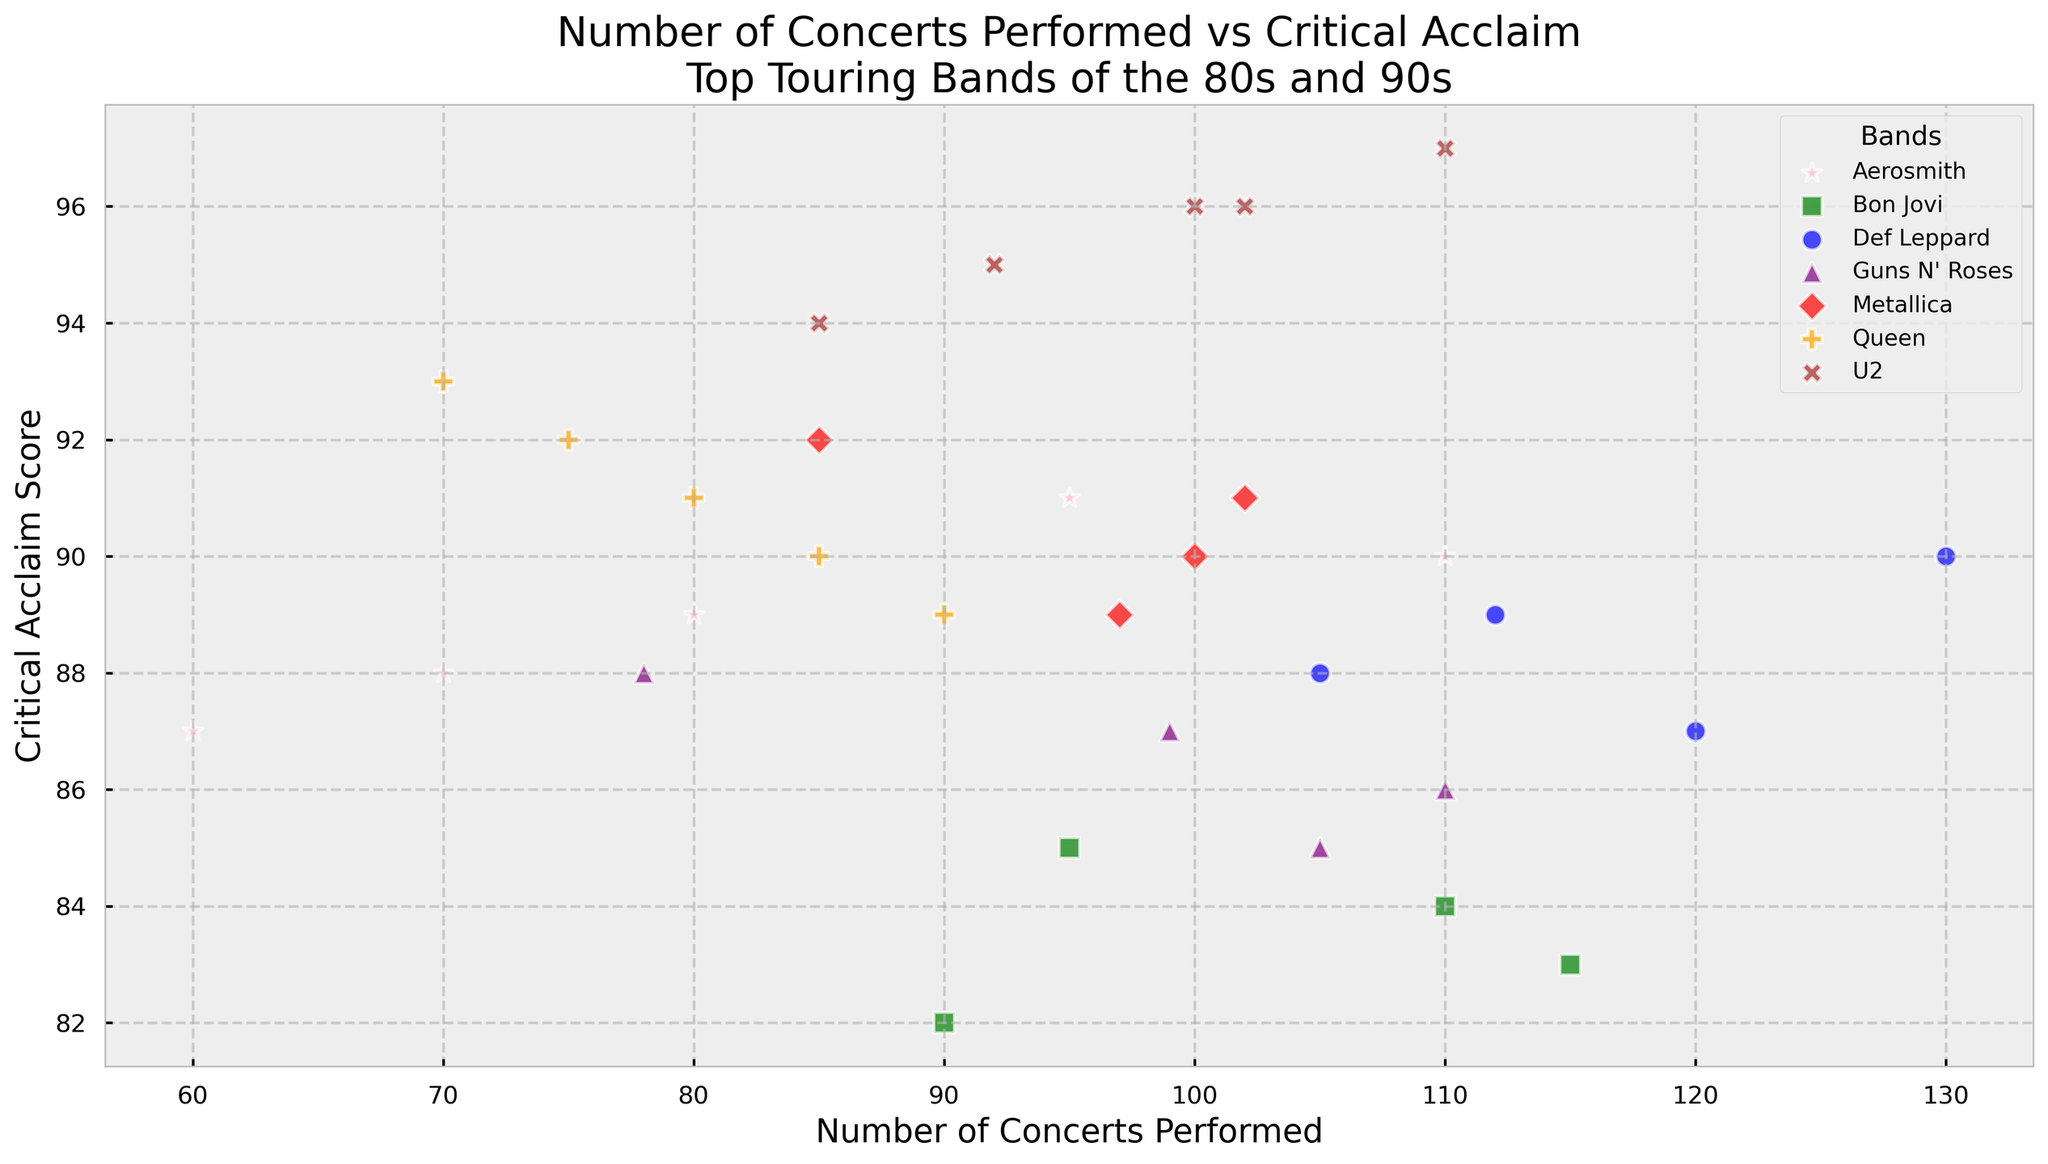What is the average critical acclaim score for concerts performed by U2? To find the average critical acclaim score for U2, identify the data points for U2, sum their critical acclaim scores, and divide by the number of data points. The scores are 94, 95, 96, 97, 96. Sum is 478. There are 5 data points, so the average is 478 / 5.
Answer: 95.6 Which band performed the most concerts in a single year, and what is the critical acclaim score for that year? To determine which band performed the most concerts, look for the highest value on the x-axis and identify the band. The band with the most concerts is Def Leppard with 130 concerts in 1987, and the score is 90.
Answer: Def Leppard, 90 Between Metallica and Guns N' Roses, which band had a year with the highest critical acclaim score, and what was the score? Compare the maximum y-axis values for Metallica and Guns N' Roses. Metallica's highest score is 92 in 1986. Guns N' Roses' highest score is 88 in 1987. Therefore, Metallica has the higher score with 92.
Answer: Metallica, 92 Did Def Leppard ever achieve a critical acclaim score greater than or equal to 90? If yes, in which years? To check, look at the critical acclaim scores for Def Leppard above or equal to 90. Def Leppard achieved a score of 90 in 1987.
Answer: Yes, 1987 What is the combined number of concerts performed by Bon Jovi in the years 1986, 1987, and 1989? Add the concerts performed by Bon Jovi in these years: 95 (1986), 110 (1987), and 115 (1989). The combined number is 95 + 110 + 115.
Answer: 320 How many concerts did Guns N' Roses perform compared to Aerosmith, where both bands have the same critical acclaim score? Identify the matching critical acclaim scores and compare the number of concerts. Both have a score of 88. Guns N' Roses in 1987 performed 78 concerts, and Aerosmith in 1980 performed 70 concerts.
Answer: Guns N' Roses performed 8 more concerts Which band has the most widespread (maximum range) critical acclaim scores? Calculate the range (max - min) of critical acclaim scores for each band. Def Leppard (90 - 87 = 3), Bon Jovi (85 - 82 = 3), Metallica (92 - 89 = 3), Guns N' Roses (88 - 85 = 3), Queen (93 - 89 = 4), U2 (97 - 94 = 3), Aerosmith (91 - 87 = 4). The widest range is for Queen and Aerosmith with a range of 4.
Answer: Queen and Aerosmith Do any bands have years where they performed exactly the same number of concerts and received the same critical acclaim score? Check if any data points overlap exactly for concerts performed and critical acclaim scores. No overlapping data points are observed.
Answer: No, none 